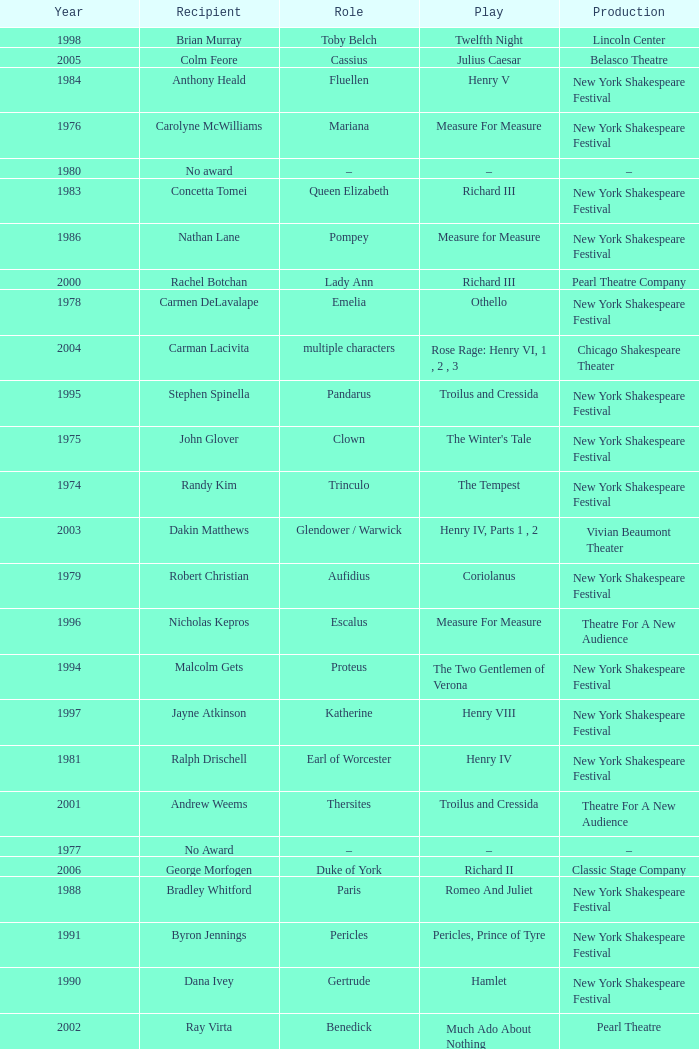Name the recipient of much ado about nothing for 1973 Barnard Hughes. 